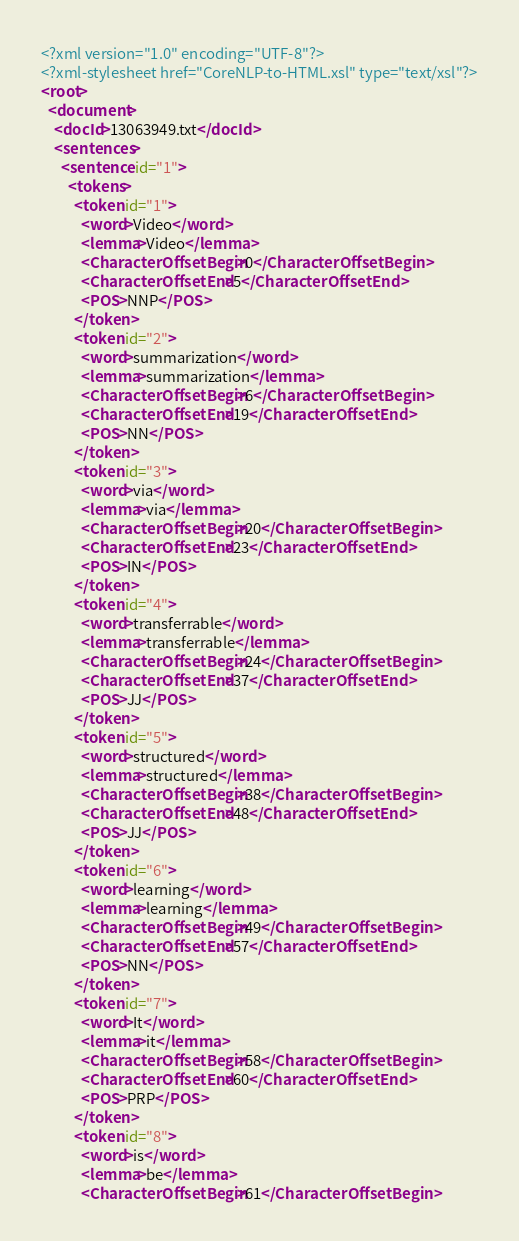<code> <loc_0><loc_0><loc_500><loc_500><_XML_><?xml version="1.0" encoding="UTF-8"?>
<?xml-stylesheet href="CoreNLP-to-HTML.xsl" type="text/xsl"?>
<root>
  <document>
    <docId>13063949.txt</docId>
    <sentences>
      <sentence id="1">
        <tokens>
          <token id="1">
            <word>Video</word>
            <lemma>Video</lemma>
            <CharacterOffsetBegin>0</CharacterOffsetBegin>
            <CharacterOffsetEnd>5</CharacterOffsetEnd>
            <POS>NNP</POS>
          </token>
          <token id="2">
            <word>summarization</word>
            <lemma>summarization</lemma>
            <CharacterOffsetBegin>6</CharacterOffsetBegin>
            <CharacterOffsetEnd>19</CharacterOffsetEnd>
            <POS>NN</POS>
          </token>
          <token id="3">
            <word>via</word>
            <lemma>via</lemma>
            <CharacterOffsetBegin>20</CharacterOffsetBegin>
            <CharacterOffsetEnd>23</CharacterOffsetEnd>
            <POS>IN</POS>
          </token>
          <token id="4">
            <word>transferrable</word>
            <lemma>transferrable</lemma>
            <CharacterOffsetBegin>24</CharacterOffsetBegin>
            <CharacterOffsetEnd>37</CharacterOffsetEnd>
            <POS>JJ</POS>
          </token>
          <token id="5">
            <word>structured</word>
            <lemma>structured</lemma>
            <CharacterOffsetBegin>38</CharacterOffsetBegin>
            <CharacterOffsetEnd>48</CharacterOffsetEnd>
            <POS>JJ</POS>
          </token>
          <token id="6">
            <word>learning</word>
            <lemma>learning</lemma>
            <CharacterOffsetBegin>49</CharacterOffsetBegin>
            <CharacterOffsetEnd>57</CharacterOffsetEnd>
            <POS>NN</POS>
          </token>
          <token id="7">
            <word>It</word>
            <lemma>it</lemma>
            <CharacterOffsetBegin>58</CharacterOffsetBegin>
            <CharacterOffsetEnd>60</CharacterOffsetEnd>
            <POS>PRP</POS>
          </token>
          <token id="8">
            <word>is</word>
            <lemma>be</lemma>
            <CharacterOffsetBegin>61</CharacterOffsetBegin></code> 